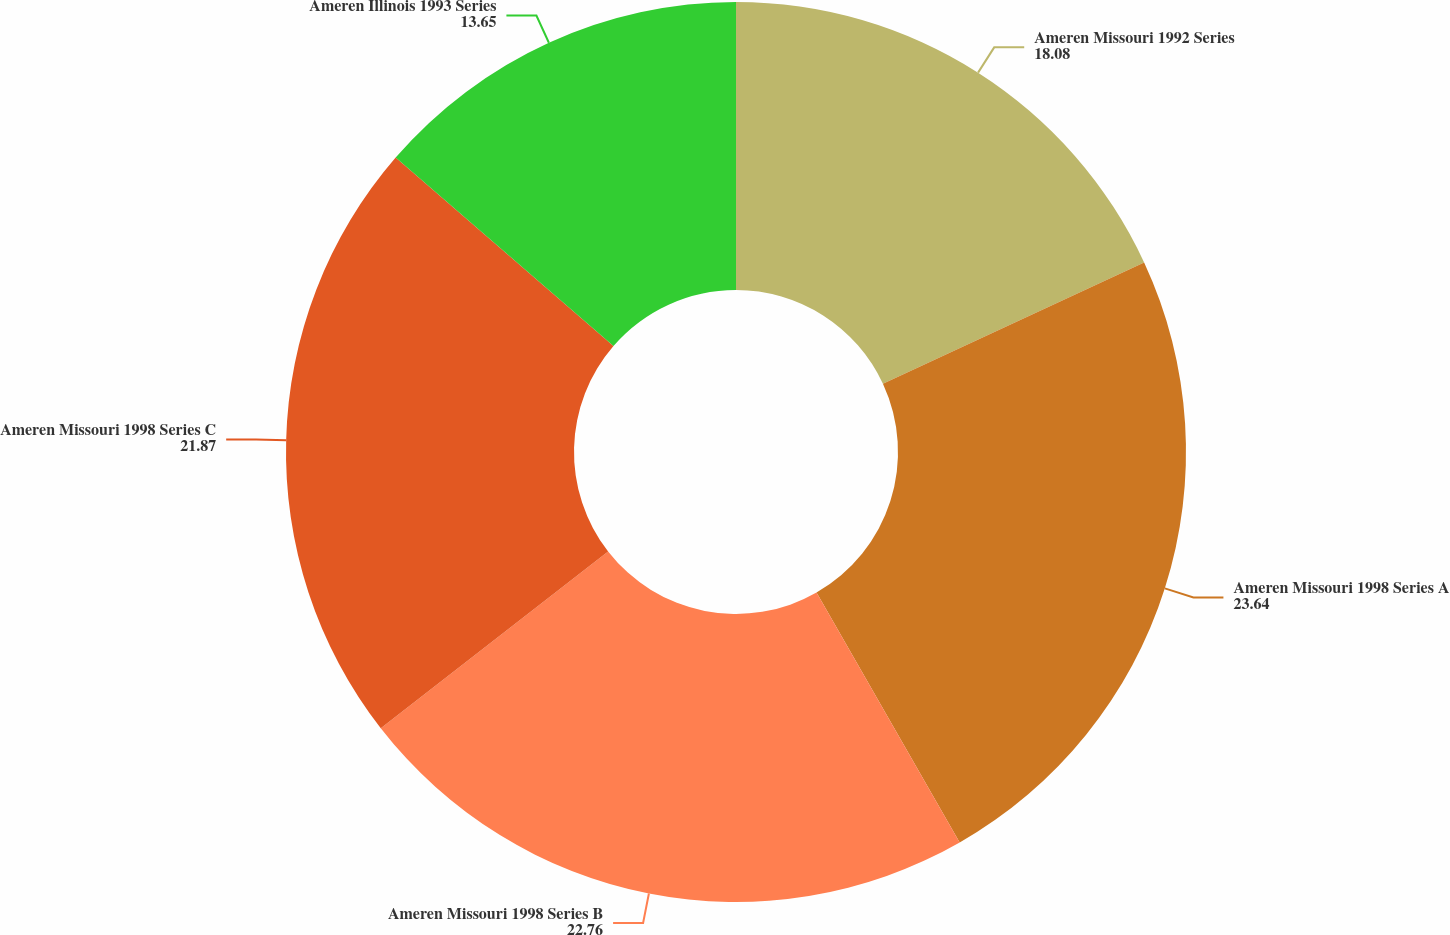Convert chart to OTSL. <chart><loc_0><loc_0><loc_500><loc_500><pie_chart><fcel>Ameren Missouri 1992 Series<fcel>Ameren Missouri 1998 Series A<fcel>Ameren Missouri 1998 Series B<fcel>Ameren Missouri 1998 Series C<fcel>Ameren Illinois 1993 Series<nl><fcel>18.08%<fcel>23.64%<fcel>22.76%<fcel>21.87%<fcel>13.65%<nl></chart> 